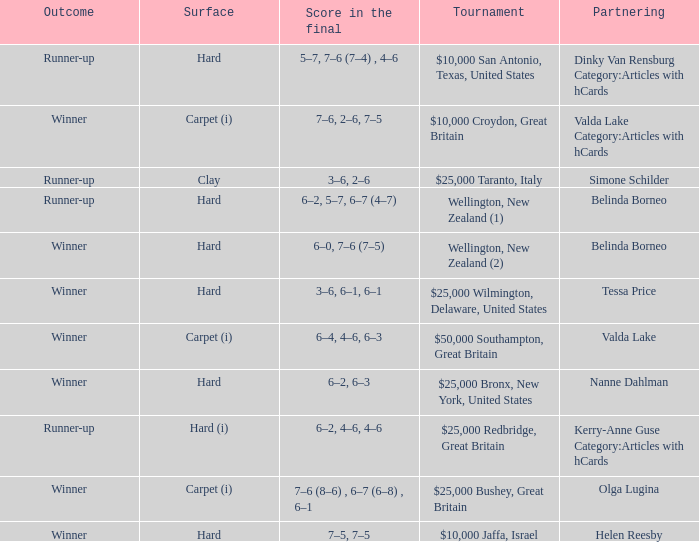What was the final score for the match with a partnering of Tessa Price? 3–6, 6–1, 6–1. 